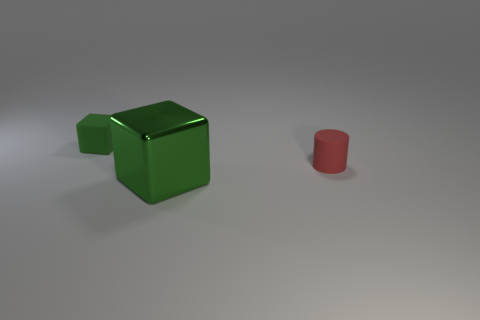Are there any big blocks right of the tiny red thing?
Your response must be concise. No. What color is the thing that is the same size as the matte cube?
Keep it short and to the point. Red. What number of things are blocks behind the metal object or tiny red matte objects?
Your answer should be very brief. 2. How big is the object that is both behind the big metallic thing and to the right of the green matte object?
Offer a very short reply. Small. What size is the metal thing that is the same color as the tiny block?
Make the answer very short. Large. What number of other things are there of the same size as the shiny block?
Offer a terse response. 0. What color is the cube behind the small thing right of the green block that is in front of the tiny green cube?
Provide a short and direct response. Green. There is a thing that is both left of the red cylinder and to the right of the small matte block; what is its shape?
Make the answer very short. Cube. What number of other objects are there of the same shape as the tiny green object?
Offer a very short reply. 1. There is a small matte object that is on the left side of the matte object that is on the right side of the block to the left of the large green metallic thing; what shape is it?
Offer a very short reply. Cube. 